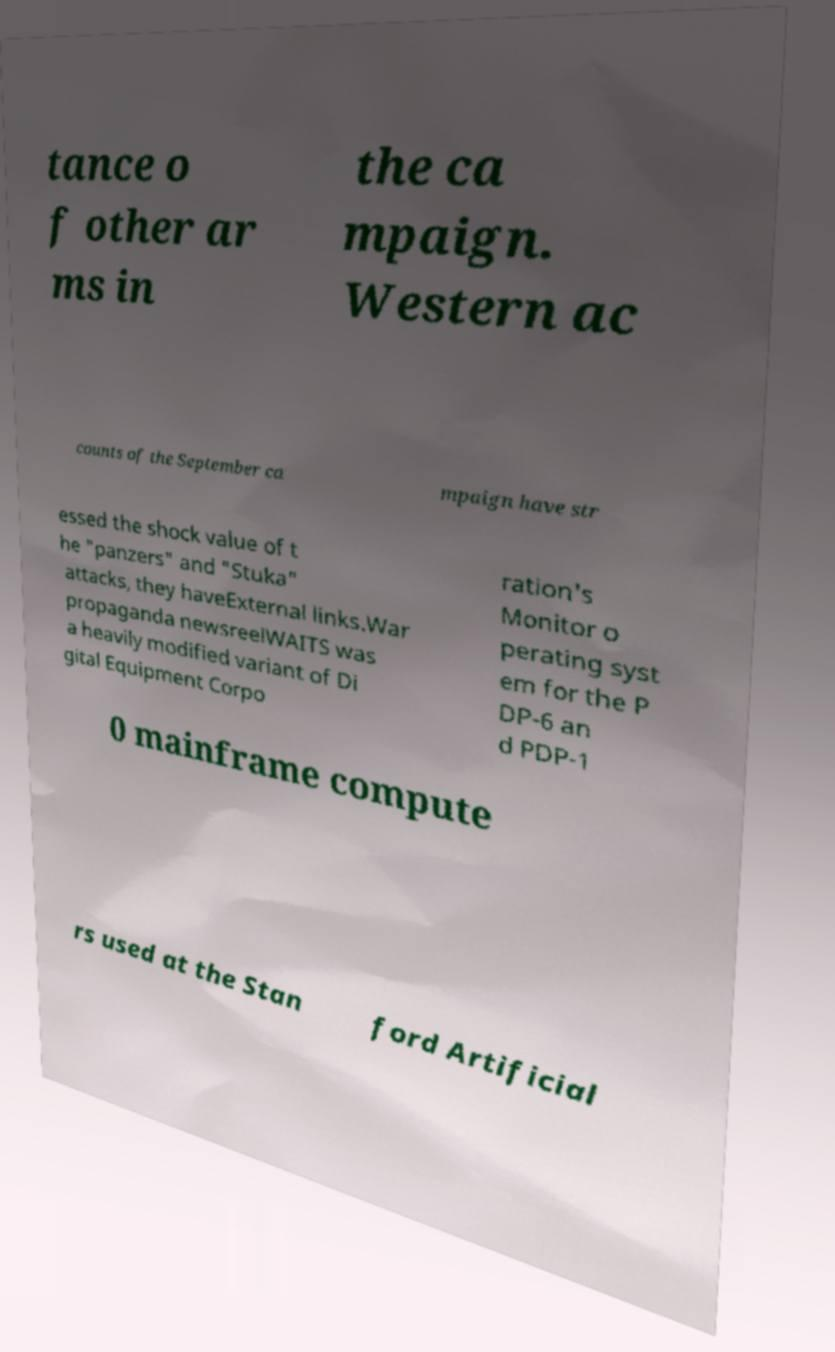There's text embedded in this image that I need extracted. Can you transcribe it verbatim? tance o f other ar ms in the ca mpaign. Western ac counts of the September ca mpaign have str essed the shock value of t he "panzers" and "Stuka" attacks, they haveExternal links.War propaganda newsreelWAITS was a heavily modified variant of Di gital Equipment Corpo ration's Monitor o perating syst em for the P DP-6 an d PDP-1 0 mainframe compute rs used at the Stan ford Artificial 